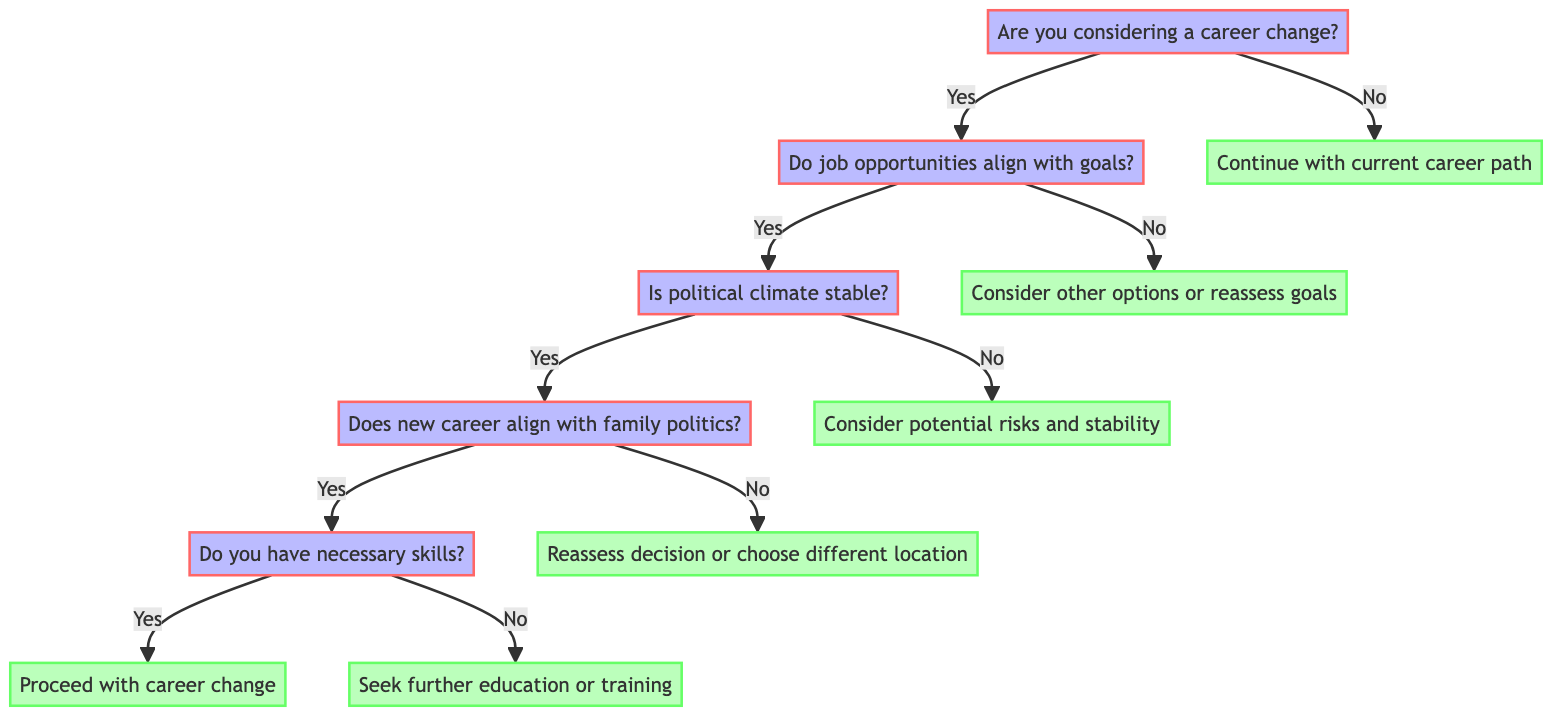What is the first question in the decision tree? The first question is located at the top of the decision tree and is "Are you considering a career change?" This serves as the starting point for all subsequent decisions.
Answer: Are you considering a career change? If the answer to the second question is no, what action should be taken? If the answer to the second question ("Do job opportunities in the new field align with your career goals?") is no, the diagram indicates to "Consider other career options or reassess goals." This is the next node to follow based on that answer.
Answer: Consider other career options or reassess goals How many endpoints are present in the diagram? The diagram portrays five endpoints: "Continue with current career path," "Consider other career options or reassess goals," "Consider potential risks and stability," "Reassess your career change decision or choose a different location," "Proceed with career change," and "Seek further education or training." Counting these gives a total of six endpoints.
Answer: Six What is the outcome if you answer yes to both the first and second questions? If you answer yes to both the first question ("Are you considering a career change?") and the second question ("Do job opportunities in the new field align with your career goals?"), then you proceed to the third question about the political climate in the desired location. Hence, the outcome is to continue exploring the decision tree further.
Answer: Proceed to the third question What happens if the political climate is unstable and job opportunities align with your goals? If the political climate is unstable (answering no to the third question) while job opportunities align with your goals (answering yes to the second question), the diagram directs you to "Consider potential risks and stability." This indicates a cautionary approach to the career change under uncertain political conditions.
Answer: Consider potential risks and stability What should you do if the new career does not align with family political beliefs? If the new career does not align with your family's political beliefs (answering no to the fourth question), the next step indicated in the diagram is to "Reassess your career change decision or choose a different location." This signifies a need to rethink the decision based on family values.
Answer: Reassess your career change decision or choose a different location 